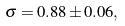<formula> <loc_0><loc_0><loc_500><loc_500>\sigma = 0 . 8 8 \pm 0 . 0 6 ,</formula> 